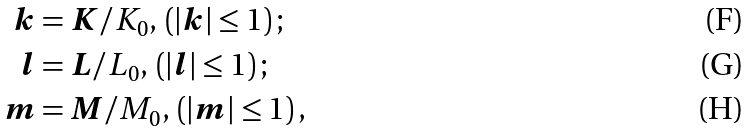Convert formula to latex. <formula><loc_0><loc_0><loc_500><loc_500>\boldsymbol k & = \boldsymbol K / K _ { 0 } , \, \left ( | \boldsymbol k | \leq 1 \right ) ; \\ \boldsymbol l & = \boldsymbol L / L _ { 0 } , \, \left ( | \boldsymbol l | \leq 1 \right ) ; \\ \boldsymbol m & = \boldsymbol M / M _ { 0 } , \, \left ( | \boldsymbol m | \leq 1 \right ) ,</formula> 